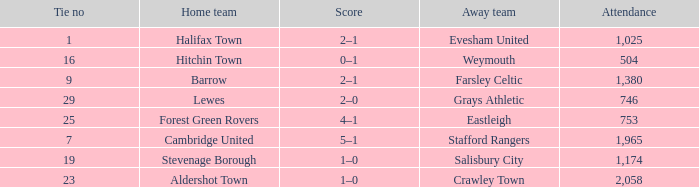How many attended tie number 19? 1174.0. 